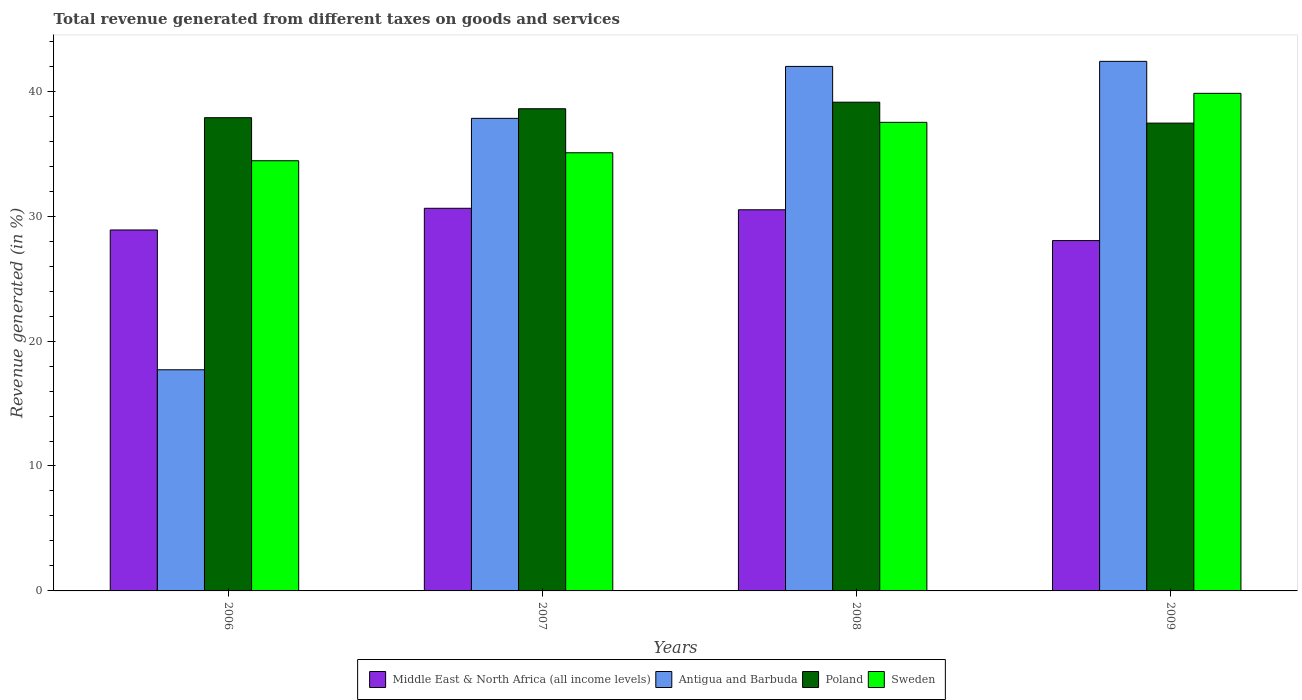How many different coloured bars are there?
Make the answer very short. 4. How many groups of bars are there?
Keep it short and to the point. 4. Are the number of bars per tick equal to the number of legend labels?
Provide a succinct answer. Yes. Are the number of bars on each tick of the X-axis equal?
Make the answer very short. Yes. How many bars are there on the 3rd tick from the left?
Make the answer very short. 4. How many bars are there on the 3rd tick from the right?
Provide a short and direct response. 4. What is the label of the 1st group of bars from the left?
Offer a very short reply. 2006. In how many cases, is the number of bars for a given year not equal to the number of legend labels?
Offer a very short reply. 0. What is the total revenue generated in Poland in 2008?
Your answer should be compact. 39.12. Across all years, what is the maximum total revenue generated in Sweden?
Give a very brief answer. 39.83. Across all years, what is the minimum total revenue generated in Sweden?
Offer a terse response. 34.43. In which year was the total revenue generated in Antigua and Barbuda minimum?
Make the answer very short. 2006. What is the total total revenue generated in Sweden in the graph?
Ensure brevity in your answer.  146.85. What is the difference between the total revenue generated in Sweden in 2008 and that in 2009?
Give a very brief answer. -2.32. What is the difference between the total revenue generated in Middle East & North Africa (all income levels) in 2007 and the total revenue generated in Sweden in 2008?
Give a very brief answer. -6.88. What is the average total revenue generated in Middle East & North Africa (all income levels) per year?
Make the answer very short. 29.52. In the year 2006, what is the difference between the total revenue generated in Antigua and Barbuda and total revenue generated in Middle East & North Africa (all income levels)?
Offer a very short reply. -11.19. In how many years, is the total revenue generated in Antigua and Barbuda greater than 4 %?
Your response must be concise. 4. What is the ratio of the total revenue generated in Poland in 2006 to that in 2007?
Make the answer very short. 0.98. Is the total revenue generated in Antigua and Barbuda in 2006 less than that in 2008?
Make the answer very short. Yes. What is the difference between the highest and the second highest total revenue generated in Antigua and Barbuda?
Make the answer very short. 0.41. What is the difference between the highest and the lowest total revenue generated in Poland?
Give a very brief answer. 1.68. In how many years, is the total revenue generated in Sweden greater than the average total revenue generated in Sweden taken over all years?
Your answer should be very brief. 2. Is the sum of the total revenue generated in Poland in 2006 and 2007 greater than the maximum total revenue generated in Middle East & North Africa (all income levels) across all years?
Your response must be concise. Yes. Is it the case that in every year, the sum of the total revenue generated in Middle East & North Africa (all income levels) and total revenue generated in Sweden is greater than the sum of total revenue generated in Poland and total revenue generated in Antigua and Barbuda?
Provide a short and direct response. Yes. What does the 3rd bar from the left in 2009 represents?
Your response must be concise. Poland. What does the 2nd bar from the right in 2006 represents?
Provide a succinct answer. Poland. Does the graph contain any zero values?
Ensure brevity in your answer.  No. How are the legend labels stacked?
Ensure brevity in your answer.  Horizontal. What is the title of the graph?
Your answer should be very brief. Total revenue generated from different taxes on goods and services. What is the label or title of the Y-axis?
Ensure brevity in your answer.  Revenue generated (in %). What is the Revenue generated (in %) of Middle East & North Africa (all income levels) in 2006?
Provide a short and direct response. 28.89. What is the Revenue generated (in %) of Antigua and Barbuda in 2006?
Keep it short and to the point. 17.7. What is the Revenue generated (in %) in Poland in 2006?
Your answer should be very brief. 37.88. What is the Revenue generated (in %) of Sweden in 2006?
Provide a short and direct response. 34.43. What is the Revenue generated (in %) in Middle East & North Africa (all income levels) in 2007?
Provide a succinct answer. 30.63. What is the Revenue generated (in %) of Antigua and Barbuda in 2007?
Your response must be concise. 37.83. What is the Revenue generated (in %) of Poland in 2007?
Your response must be concise. 38.6. What is the Revenue generated (in %) of Sweden in 2007?
Make the answer very short. 35.07. What is the Revenue generated (in %) in Middle East & North Africa (all income levels) in 2008?
Give a very brief answer. 30.51. What is the Revenue generated (in %) in Antigua and Barbuda in 2008?
Give a very brief answer. 41.98. What is the Revenue generated (in %) in Poland in 2008?
Offer a very short reply. 39.12. What is the Revenue generated (in %) in Sweden in 2008?
Offer a very short reply. 37.51. What is the Revenue generated (in %) in Middle East & North Africa (all income levels) in 2009?
Ensure brevity in your answer.  28.04. What is the Revenue generated (in %) in Antigua and Barbuda in 2009?
Make the answer very short. 42.39. What is the Revenue generated (in %) of Poland in 2009?
Your response must be concise. 37.45. What is the Revenue generated (in %) of Sweden in 2009?
Your answer should be compact. 39.83. Across all years, what is the maximum Revenue generated (in %) in Middle East & North Africa (all income levels)?
Provide a short and direct response. 30.63. Across all years, what is the maximum Revenue generated (in %) in Antigua and Barbuda?
Make the answer very short. 42.39. Across all years, what is the maximum Revenue generated (in %) of Poland?
Offer a terse response. 39.12. Across all years, what is the maximum Revenue generated (in %) in Sweden?
Ensure brevity in your answer.  39.83. Across all years, what is the minimum Revenue generated (in %) of Middle East & North Africa (all income levels)?
Offer a very short reply. 28.04. Across all years, what is the minimum Revenue generated (in %) in Antigua and Barbuda?
Your response must be concise. 17.7. Across all years, what is the minimum Revenue generated (in %) of Poland?
Ensure brevity in your answer.  37.45. Across all years, what is the minimum Revenue generated (in %) in Sweden?
Your answer should be very brief. 34.43. What is the total Revenue generated (in %) of Middle East & North Africa (all income levels) in the graph?
Ensure brevity in your answer.  118.07. What is the total Revenue generated (in %) in Antigua and Barbuda in the graph?
Your answer should be compact. 139.9. What is the total Revenue generated (in %) of Poland in the graph?
Provide a short and direct response. 153.04. What is the total Revenue generated (in %) of Sweden in the graph?
Your answer should be very brief. 146.84. What is the difference between the Revenue generated (in %) of Middle East & North Africa (all income levels) in 2006 and that in 2007?
Offer a very short reply. -1.74. What is the difference between the Revenue generated (in %) in Antigua and Barbuda in 2006 and that in 2007?
Keep it short and to the point. -20.13. What is the difference between the Revenue generated (in %) in Poland in 2006 and that in 2007?
Provide a succinct answer. -0.72. What is the difference between the Revenue generated (in %) of Sweden in 2006 and that in 2007?
Your answer should be very brief. -0.64. What is the difference between the Revenue generated (in %) of Middle East & North Africa (all income levels) in 2006 and that in 2008?
Your answer should be very brief. -1.62. What is the difference between the Revenue generated (in %) of Antigua and Barbuda in 2006 and that in 2008?
Your answer should be compact. -24.28. What is the difference between the Revenue generated (in %) of Poland in 2006 and that in 2008?
Offer a terse response. -1.24. What is the difference between the Revenue generated (in %) in Sweden in 2006 and that in 2008?
Provide a succinct answer. -3.07. What is the difference between the Revenue generated (in %) in Middle East & North Africa (all income levels) in 2006 and that in 2009?
Your answer should be very brief. 0.85. What is the difference between the Revenue generated (in %) of Antigua and Barbuda in 2006 and that in 2009?
Your answer should be very brief. -24.69. What is the difference between the Revenue generated (in %) of Poland in 2006 and that in 2009?
Give a very brief answer. 0.43. What is the difference between the Revenue generated (in %) in Sweden in 2006 and that in 2009?
Your answer should be compact. -5.39. What is the difference between the Revenue generated (in %) in Middle East & North Africa (all income levels) in 2007 and that in 2008?
Give a very brief answer. 0.12. What is the difference between the Revenue generated (in %) in Antigua and Barbuda in 2007 and that in 2008?
Your response must be concise. -4.16. What is the difference between the Revenue generated (in %) in Poland in 2007 and that in 2008?
Offer a terse response. -0.52. What is the difference between the Revenue generated (in %) in Sweden in 2007 and that in 2008?
Offer a terse response. -2.44. What is the difference between the Revenue generated (in %) of Middle East & North Africa (all income levels) in 2007 and that in 2009?
Make the answer very short. 2.59. What is the difference between the Revenue generated (in %) in Antigua and Barbuda in 2007 and that in 2009?
Give a very brief answer. -4.56. What is the difference between the Revenue generated (in %) of Poland in 2007 and that in 2009?
Ensure brevity in your answer.  1.15. What is the difference between the Revenue generated (in %) of Sweden in 2007 and that in 2009?
Give a very brief answer. -4.76. What is the difference between the Revenue generated (in %) of Middle East & North Africa (all income levels) in 2008 and that in 2009?
Your answer should be compact. 2.47. What is the difference between the Revenue generated (in %) in Antigua and Barbuda in 2008 and that in 2009?
Ensure brevity in your answer.  -0.41. What is the difference between the Revenue generated (in %) of Poland in 2008 and that in 2009?
Your answer should be compact. 1.68. What is the difference between the Revenue generated (in %) in Sweden in 2008 and that in 2009?
Offer a terse response. -2.32. What is the difference between the Revenue generated (in %) in Middle East & North Africa (all income levels) in 2006 and the Revenue generated (in %) in Antigua and Barbuda in 2007?
Provide a succinct answer. -8.93. What is the difference between the Revenue generated (in %) of Middle East & North Africa (all income levels) in 2006 and the Revenue generated (in %) of Poland in 2007?
Make the answer very short. -9.7. What is the difference between the Revenue generated (in %) of Middle East & North Africa (all income levels) in 2006 and the Revenue generated (in %) of Sweden in 2007?
Give a very brief answer. -6.18. What is the difference between the Revenue generated (in %) in Antigua and Barbuda in 2006 and the Revenue generated (in %) in Poland in 2007?
Make the answer very short. -20.9. What is the difference between the Revenue generated (in %) of Antigua and Barbuda in 2006 and the Revenue generated (in %) of Sweden in 2007?
Ensure brevity in your answer.  -17.37. What is the difference between the Revenue generated (in %) in Poland in 2006 and the Revenue generated (in %) in Sweden in 2007?
Provide a succinct answer. 2.81. What is the difference between the Revenue generated (in %) in Middle East & North Africa (all income levels) in 2006 and the Revenue generated (in %) in Antigua and Barbuda in 2008?
Your answer should be very brief. -13.09. What is the difference between the Revenue generated (in %) in Middle East & North Africa (all income levels) in 2006 and the Revenue generated (in %) in Poland in 2008?
Keep it short and to the point. -10.23. What is the difference between the Revenue generated (in %) of Middle East & North Africa (all income levels) in 2006 and the Revenue generated (in %) of Sweden in 2008?
Your answer should be compact. -8.62. What is the difference between the Revenue generated (in %) of Antigua and Barbuda in 2006 and the Revenue generated (in %) of Poland in 2008?
Your response must be concise. -21.42. What is the difference between the Revenue generated (in %) in Antigua and Barbuda in 2006 and the Revenue generated (in %) in Sweden in 2008?
Provide a short and direct response. -19.81. What is the difference between the Revenue generated (in %) of Poland in 2006 and the Revenue generated (in %) of Sweden in 2008?
Ensure brevity in your answer.  0.37. What is the difference between the Revenue generated (in %) in Middle East & North Africa (all income levels) in 2006 and the Revenue generated (in %) in Antigua and Barbuda in 2009?
Offer a terse response. -13.5. What is the difference between the Revenue generated (in %) in Middle East & North Africa (all income levels) in 2006 and the Revenue generated (in %) in Poland in 2009?
Your response must be concise. -8.55. What is the difference between the Revenue generated (in %) in Middle East & North Africa (all income levels) in 2006 and the Revenue generated (in %) in Sweden in 2009?
Your answer should be compact. -10.94. What is the difference between the Revenue generated (in %) in Antigua and Barbuda in 2006 and the Revenue generated (in %) in Poland in 2009?
Your answer should be compact. -19.74. What is the difference between the Revenue generated (in %) of Antigua and Barbuda in 2006 and the Revenue generated (in %) of Sweden in 2009?
Make the answer very short. -22.13. What is the difference between the Revenue generated (in %) in Poland in 2006 and the Revenue generated (in %) in Sweden in 2009?
Your answer should be compact. -1.95. What is the difference between the Revenue generated (in %) in Middle East & North Africa (all income levels) in 2007 and the Revenue generated (in %) in Antigua and Barbuda in 2008?
Offer a terse response. -11.36. What is the difference between the Revenue generated (in %) of Middle East & North Africa (all income levels) in 2007 and the Revenue generated (in %) of Poland in 2008?
Keep it short and to the point. -8.49. What is the difference between the Revenue generated (in %) of Middle East & North Africa (all income levels) in 2007 and the Revenue generated (in %) of Sweden in 2008?
Ensure brevity in your answer.  -6.88. What is the difference between the Revenue generated (in %) in Antigua and Barbuda in 2007 and the Revenue generated (in %) in Poland in 2008?
Provide a short and direct response. -1.29. What is the difference between the Revenue generated (in %) in Antigua and Barbuda in 2007 and the Revenue generated (in %) in Sweden in 2008?
Keep it short and to the point. 0.32. What is the difference between the Revenue generated (in %) of Poland in 2007 and the Revenue generated (in %) of Sweden in 2008?
Give a very brief answer. 1.09. What is the difference between the Revenue generated (in %) of Middle East & North Africa (all income levels) in 2007 and the Revenue generated (in %) of Antigua and Barbuda in 2009?
Offer a terse response. -11.76. What is the difference between the Revenue generated (in %) of Middle East & North Africa (all income levels) in 2007 and the Revenue generated (in %) of Poland in 2009?
Make the answer very short. -6.82. What is the difference between the Revenue generated (in %) of Middle East & North Africa (all income levels) in 2007 and the Revenue generated (in %) of Sweden in 2009?
Give a very brief answer. -9.2. What is the difference between the Revenue generated (in %) of Antigua and Barbuda in 2007 and the Revenue generated (in %) of Poland in 2009?
Offer a very short reply. 0.38. What is the difference between the Revenue generated (in %) in Antigua and Barbuda in 2007 and the Revenue generated (in %) in Sweden in 2009?
Your response must be concise. -2. What is the difference between the Revenue generated (in %) of Poland in 2007 and the Revenue generated (in %) of Sweden in 2009?
Give a very brief answer. -1.23. What is the difference between the Revenue generated (in %) of Middle East & North Africa (all income levels) in 2008 and the Revenue generated (in %) of Antigua and Barbuda in 2009?
Give a very brief answer. -11.88. What is the difference between the Revenue generated (in %) in Middle East & North Africa (all income levels) in 2008 and the Revenue generated (in %) in Poland in 2009?
Your answer should be very brief. -6.94. What is the difference between the Revenue generated (in %) of Middle East & North Africa (all income levels) in 2008 and the Revenue generated (in %) of Sweden in 2009?
Make the answer very short. -9.32. What is the difference between the Revenue generated (in %) in Antigua and Barbuda in 2008 and the Revenue generated (in %) in Poland in 2009?
Make the answer very short. 4.54. What is the difference between the Revenue generated (in %) of Antigua and Barbuda in 2008 and the Revenue generated (in %) of Sweden in 2009?
Offer a very short reply. 2.16. What is the difference between the Revenue generated (in %) of Poland in 2008 and the Revenue generated (in %) of Sweden in 2009?
Your response must be concise. -0.71. What is the average Revenue generated (in %) in Middle East & North Africa (all income levels) per year?
Provide a succinct answer. 29.52. What is the average Revenue generated (in %) of Antigua and Barbuda per year?
Your answer should be compact. 34.98. What is the average Revenue generated (in %) in Poland per year?
Provide a succinct answer. 38.26. What is the average Revenue generated (in %) in Sweden per year?
Give a very brief answer. 36.71. In the year 2006, what is the difference between the Revenue generated (in %) in Middle East & North Africa (all income levels) and Revenue generated (in %) in Antigua and Barbuda?
Your answer should be very brief. 11.19. In the year 2006, what is the difference between the Revenue generated (in %) in Middle East & North Africa (all income levels) and Revenue generated (in %) in Poland?
Offer a very short reply. -8.99. In the year 2006, what is the difference between the Revenue generated (in %) in Middle East & North Africa (all income levels) and Revenue generated (in %) in Sweden?
Ensure brevity in your answer.  -5.54. In the year 2006, what is the difference between the Revenue generated (in %) in Antigua and Barbuda and Revenue generated (in %) in Poland?
Offer a very short reply. -20.18. In the year 2006, what is the difference between the Revenue generated (in %) in Antigua and Barbuda and Revenue generated (in %) in Sweden?
Give a very brief answer. -16.73. In the year 2006, what is the difference between the Revenue generated (in %) in Poland and Revenue generated (in %) in Sweden?
Keep it short and to the point. 3.44. In the year 2007, what is the difference between the Revenue generated (in %) of Middle East & North Africa (all income levels) and Revenue generated (in %) of Antigua and Barbuda?
Your answer should be compact. -7.2. In the year 2007, what is the difference between the Revenue generated (in %) in Middle East & North Africa (all income levels) and Revenue generated (in %) in Poland?
Keep it short and to the point. -7.97. In the year 2007, what is the difference between the Revenue generated (in %) in Middle East & North Africa (all income levels) and Revenue generated (in %) in Sweden?
Your answer should be very brief. -4.44. In the year 2007, what is the difference between the Revenue generated (in %) of Antigua and Barbuda and Revenue generated (in %) of Poland?
Your answer should be very brief. -0.77. In the year 2007, what is the difference between the Revenue generated (in %) of Antigua and Barbuda and Revenue generated (in %) of Sweden?
Your answer should be very brief. 2.75. In the year 2007, what is the difference between the Revenue generated (in %) in Poland and Revenue generated (in %) in Sweden?
Your response must be concise. 3.52. In the year 2008, what is the difference between the Revenue generated (in %) in Middle East & North Africa (all income levels) and Revenue generated (in %) in Antigua and Barbuda?
Make the answer very short. -11.48. In the year 2008, what is the difference between the Revenue generated (in %) in Middle East & North Africa (all income levels) and Revenue generated (in %) in Poland?
Provide a short and direct response. -8.61. In the year 2008, what is the difference between the Revenue generated (in %) of Middle East & North Africa (all income levels) and Revenue generated (in %) of Sweden?
Give a very brief answer. -7. In the year 2008, what is the difference between the Revenue generated (in %) in Antigua and Barbuda and Revenue generated (in %) in Poland?
Your answer should be compact. 2.86. In the year 2008, what is the difference between the Revenue generated (in %) of Antigua and Barbuda and Revenue generated (in %) of Sweden?
Your response must be concise. 4.48. In the year 2008, what is the difference between the Revenue generated (in %) in Poland and Revenue generated (in %) in Sweden?
Give a very brief answer. 1.61. In the year 2009, what is the difference between the Revenue generated (in %) of Middle East & North Africa (all income levels) and Revenue generated (in %) of Antigua and Barbuda?
Your answer should be compact. -14.35. In the year 2009, what is the difference between the Revenue generated (in %) of Middle East & North Africa (all income levels) and Revenue generated (in %) of Poland?
Offer a terse response. -9.4. In the year 2009, what is the difference between the Revenue generated (in %) in Middle East & North Africa (all income levels) and Revenue generated (in %) in Sweden?
Give a very brief answer. -11.79. In the year 2009, what is the difference between the Revenue generated (in %) of Antigua and Barbuda and Revenue generated (in %) of Poland?
Your answer should be very brief. 4.94. In the year 2009, what is the difference between the Revenue generated (in %) in Antigua and Barbuda and Revenue generated (in %) in Sweden?
Keep it short and to the point. 2.56. In the year 2009, what is the difference between the Revenue generated (in %) of Poland and Revenue generated (in %) of Sweden?
Give a very brief answer. -2.38. What is the ratio of the Revenue generated (in %) in Middle East & North Africa (all income levels) in 2006 to that in 2007?
Your response must be concise. 0.94. What is the ratio of the Revenue generated (in %) of Antigua and Barbuda in 2006 to that in 2007?
Make the answer very short. 0.47. What is the ratio of the Revenue generated (in %) in Poland in 2006 to that in 2007?
Ensure brevity in your answer.  0.98. What is the ratio of the Revenue generated (in %) of Sweden in 2006 to that in 2007?
Provide a succinct answer. 0.98. What is the ratio of the Revenue generated (in %) in Middle East & North Africa (all income levels) in 2006 to that in 2008?
Provide a short and direct response. 0.95. What is the ratio of the Revenue generated (in %) of Antigua and Barbuda in 2006 to that in 2008?
Your answer should be very brief. 0.42. What is the ratio of the Revenue generated (in %) in Poland in 2006 to that in 2008?
Your answer should be very brief. 0.97. What is the ratio of the Revenue generated (in %) in Sweden in 2006 to that in 2008?
Give a very brief answer. 0.92. What is the ratio of the Revenue generated (in %) in Middle East & North Africa (all income levels) in 2006 to that in 2009?
Your answer should be compact. 1.03. What is the ratio of the Revenue generated (in %) of Antigua and Barbuda in 2006 to that in 2009?
Your response must be concise. 0.42. What is the ratio of the Revenue generated (in %) of Poland in 2006 to that in 2009?
Give a very brief answer. 1.01. What is the ratio of the Revenue generated (in %) of Sweden in 2006 to that in 2009?
Your response must be concise. 0.86. What is the ratio of the Revenue generated (in %) of Middle East & North Africa (all income levels) in 2007 to that in 2008?
Your answer should be very brief. 1. What is the ratio of the Revenue generated (in %) in Antigua and Barbuda in 2007 to that in 2008?
Ensure brevity in your answer.  0.9. What is the ratio of the Revenue generated (in %) of Poland in 2007 to that in 2008?
Make the answer very short. 0.99. What is the ratio of the Revenue generated (in %) in Sweden in 2007 to that in 2008?
Offer a very short reply. 0.94. What is the ratio of the Revenue generated (in %) of Middle East & North Africa (all income levels) in 2007 to that in 2009?
Offer a terse response. 1.09. What is the ratio of the Revenue generated (in %) in Antigua and Barbuda in 2007 to that in 2009?
Offer a terse response. 0.89. What is the ratio of the Revenue generated (in %) in Poland in 2007 to that in 2009?
Offer a very short reply. 1.03. What is the ratio of the Revenue generated (in %) in Sweden in 2007 to that in 2009?
Give a very brief answer. 0.88. What is the ratio of the Revenue generated (in %) in Middle East & North Africa (all income levels) in 2008 to that in 2009?
Ensure brevity in your answer.  1.09. What is the ratio of the Revenue generated (in %) in Antigua and Barbuda in 2008 to that in 2009?
Offer a very short reply. 0.99. What is the ratio of the Revenue generated (in %) of Poland in 2008 to that in 2009?
Your answer should be very brief. 1.04. What is the ratio of the Revenue generated (in %) of Sweden in 2008 to that in 2009?
Offer a terse response. 0.94. What is the difference between the highest and the second highest Revenue generated (in %) in Middle East & North Africa (all income levels)?
Your answer should be very brief. 0.12. What is the difference between the highest and the second highest Revenue generated (in %) in Antigua and Barbuda?
Your response must be concise. 0.41. What is the difference between the highest and the second highest Revenue generated (in %) in Poland?
Keep it short and to the point. 0.52. What is the difference between the highest and the second highest Revenue generated (in %) of Sweden?
Make the answer very short. 2.32. What is the difference between the highest and the lowest Revenue generated (in %) of Middle East & North Africa (all income levels)?
Your answer should be very brief. 2.59. What is the difference between the highest and the lowest Revenue generated (in %) in Antigua and Barbuda?
Your answer should be compact. 24.69. What is the difference between the highest and the lowest Revenue generated (in %) in Poland?
Ensure brevity in your answer.  1.68. What is the difference between the highest and the lowest Revenue generated (in %) in Sweden?
Ensure brevity in your answer.  5.39. 